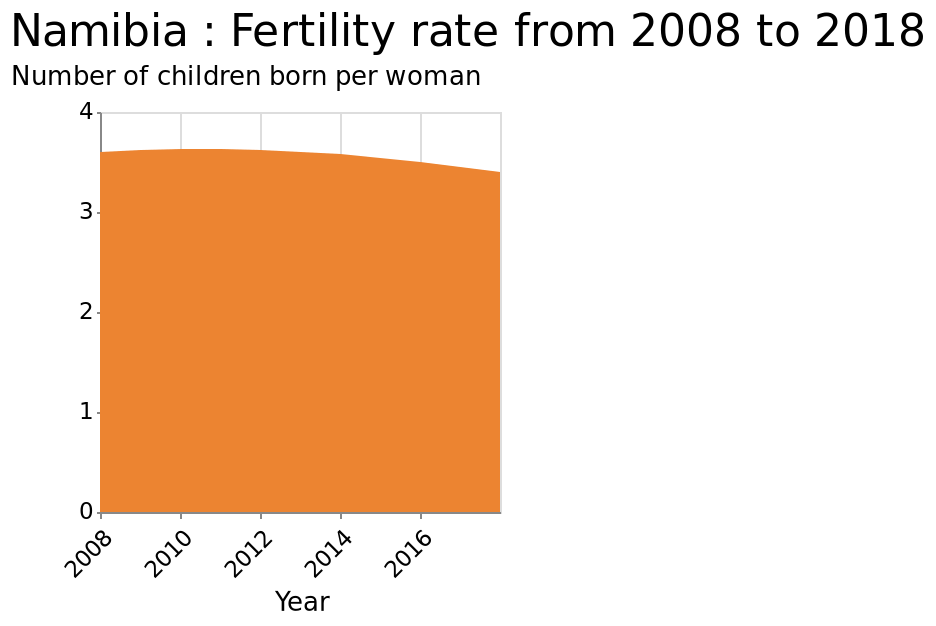<image>
What can be observed about the fertility rate of Namibian women over the past decade? Over the past decade, the fertility rate of Namibian women has been on a gradual decline. What has happened to the fertility rate of Namibian women between 2008 and 2018?  The fertility rate of Namibian women has gradually decreased. Has the fertility rate of Namibian women increased or decreased during the period of 2008-2018?  The fertility rate of Namibian women has decreased during the period of 2008-2018. What does the y-axis represent on the graph? The y-axis represents the number of children born per woman. 